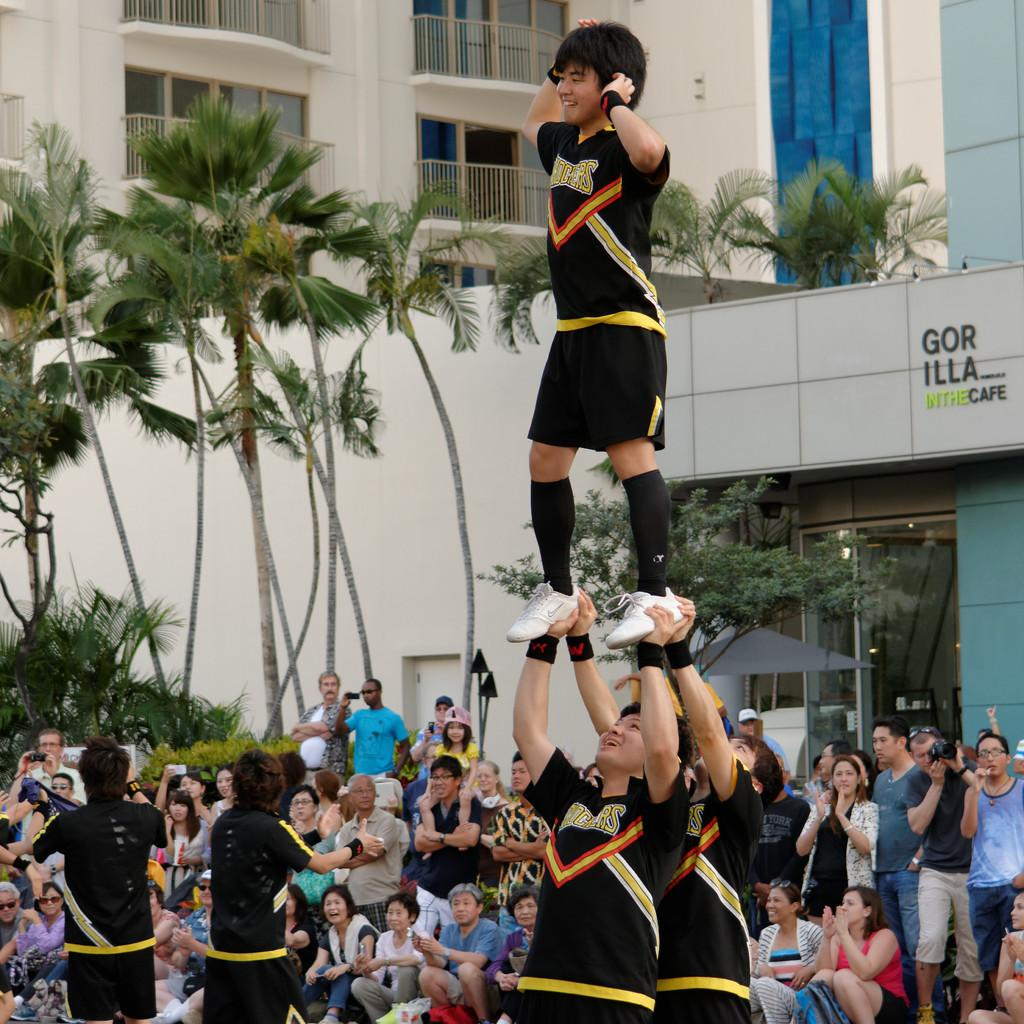<image>
Summarize the visual content of the image. Person cheerleading in front of a building that says Gorilla in the Cafe. 